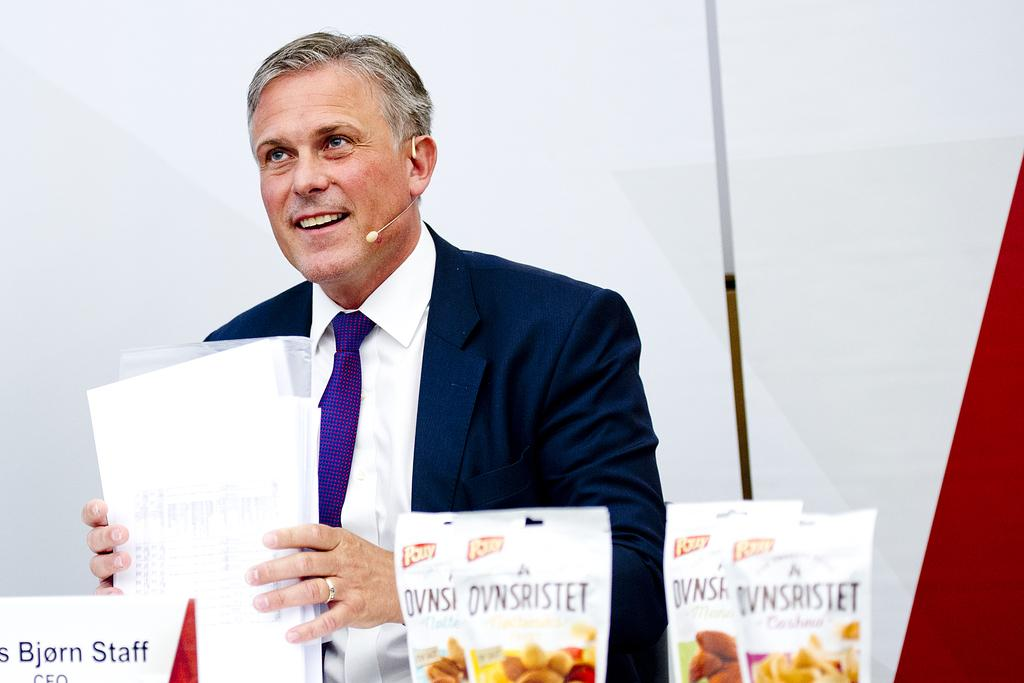Who is present in the image? There is a person in the image. What is the person's facial expression? The person has a smile on his face. What is the person holding in his hand? The person is holding papers in his hand. What objects are in front of the person? There are objects in front of the person. What is the purpose of the name board in front of the person? The name board is likely used to identify the person. What is the background behind the person? There is a wall behind the person. What type of nail can be seen in the person's hand? There is no nail present in the person's hand; they are holding papers. What road is visible in the image? There is no road visible in the image. 